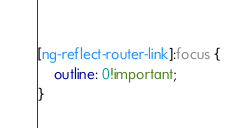<code> <loc_0><loc_0><loc_500><loc_500><_CSS_>  
[ng-reflect-router-link]:focus {
    outline: 0!important;
}</code> 